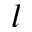Convert formula to latex. <formula><loc_0><loc_0><loc_500><loc_500>l</formula> 